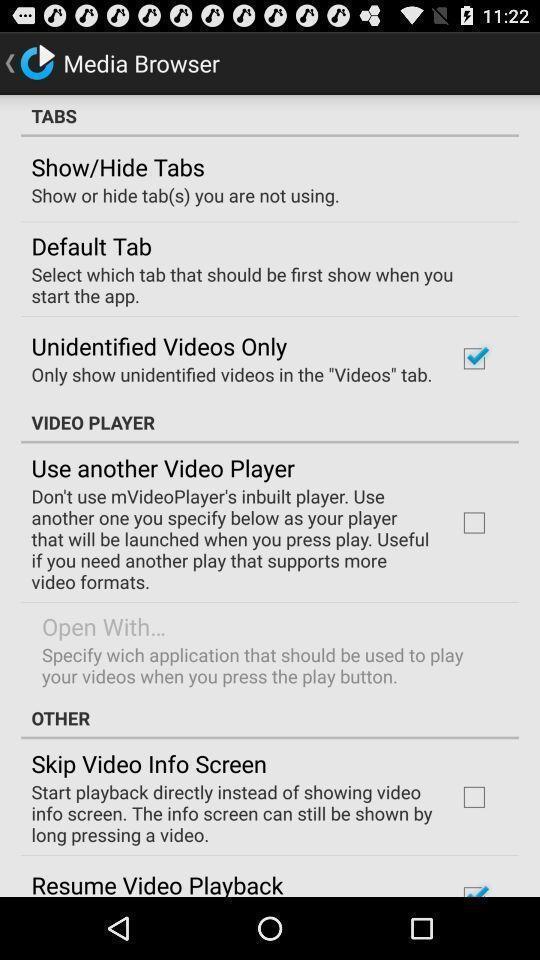Give me a narrative description of this picture. Tabs page of a browser. 